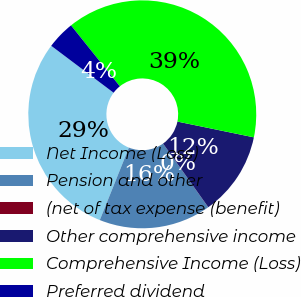<chart> <loc_0><loc_0><loc_500><loc_500><pie_chart><fcel>Net Income (Loss)<fcel>Pension and other<fcel>(net of tax expense (benefit)<fcel>Other comprehensive income<fcel>Comprehensive Income (Loss)<fcel>Preferred dividend<nl><fcel>29.19%<fcel>15.9%<fcel>0.01%<fcel>11.93%<fcel>38.99%<fcel>3.98%<nl></chart> 